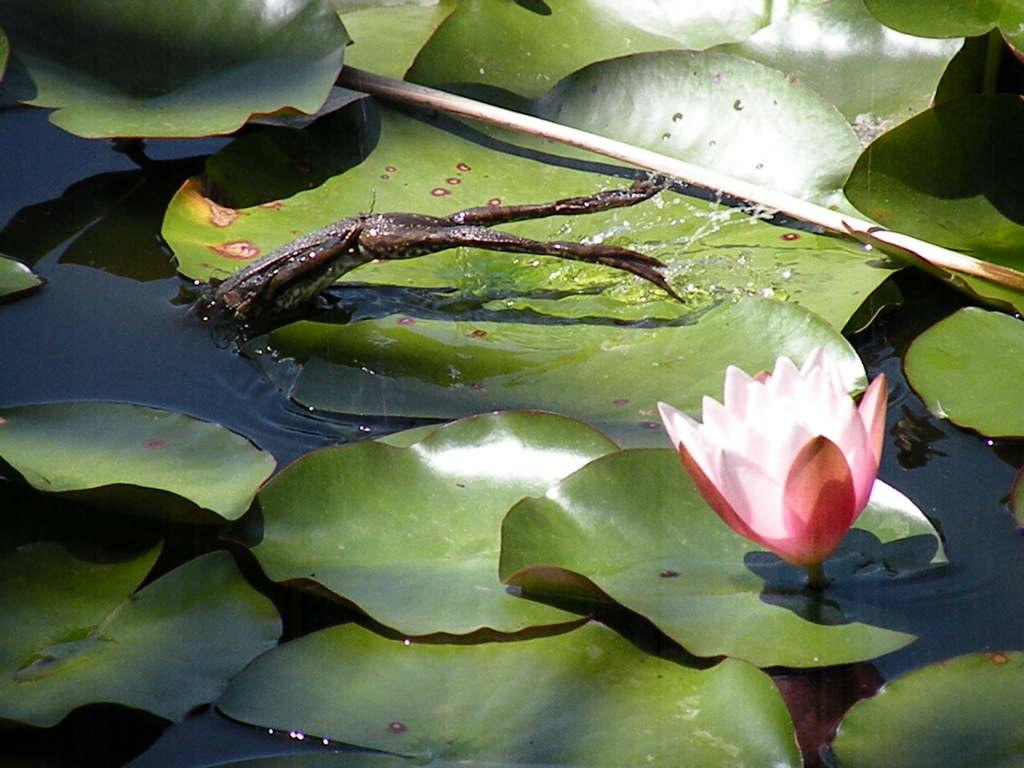What is present in the image that is typically associated with water? There is water in the image. What type of animal can be seen in the image? There is a frog in the image. What type of plant material is visible in the image? There are leaves in the image. What type of flower is present in the image? There is a pink-colored flower in the image. What type of soup is being prepared in the image? There is no soup present in the image. What direction is the father facing in the image? There is no father present in the image. 